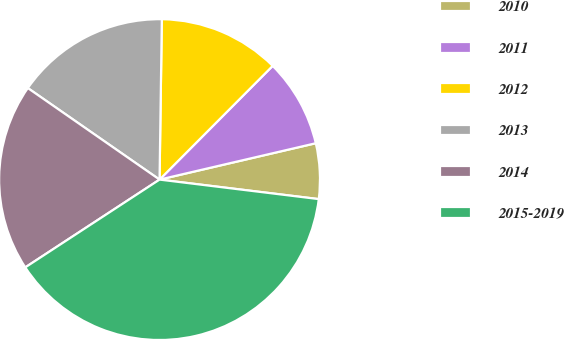Convert chart. <chart><loc_0><loc_0><loc_500><loc_500><pie_chart><fcel>2010<fcel>2011<fcel>2012<fcel>2013<fcel>2014<fcel>2015-2019<nl><fcel>5.58%<fcel>8.9%<fcel>12.23%<fcel>15.56%<fcel>18.88%<fcel>38.84%<nl></chart> 